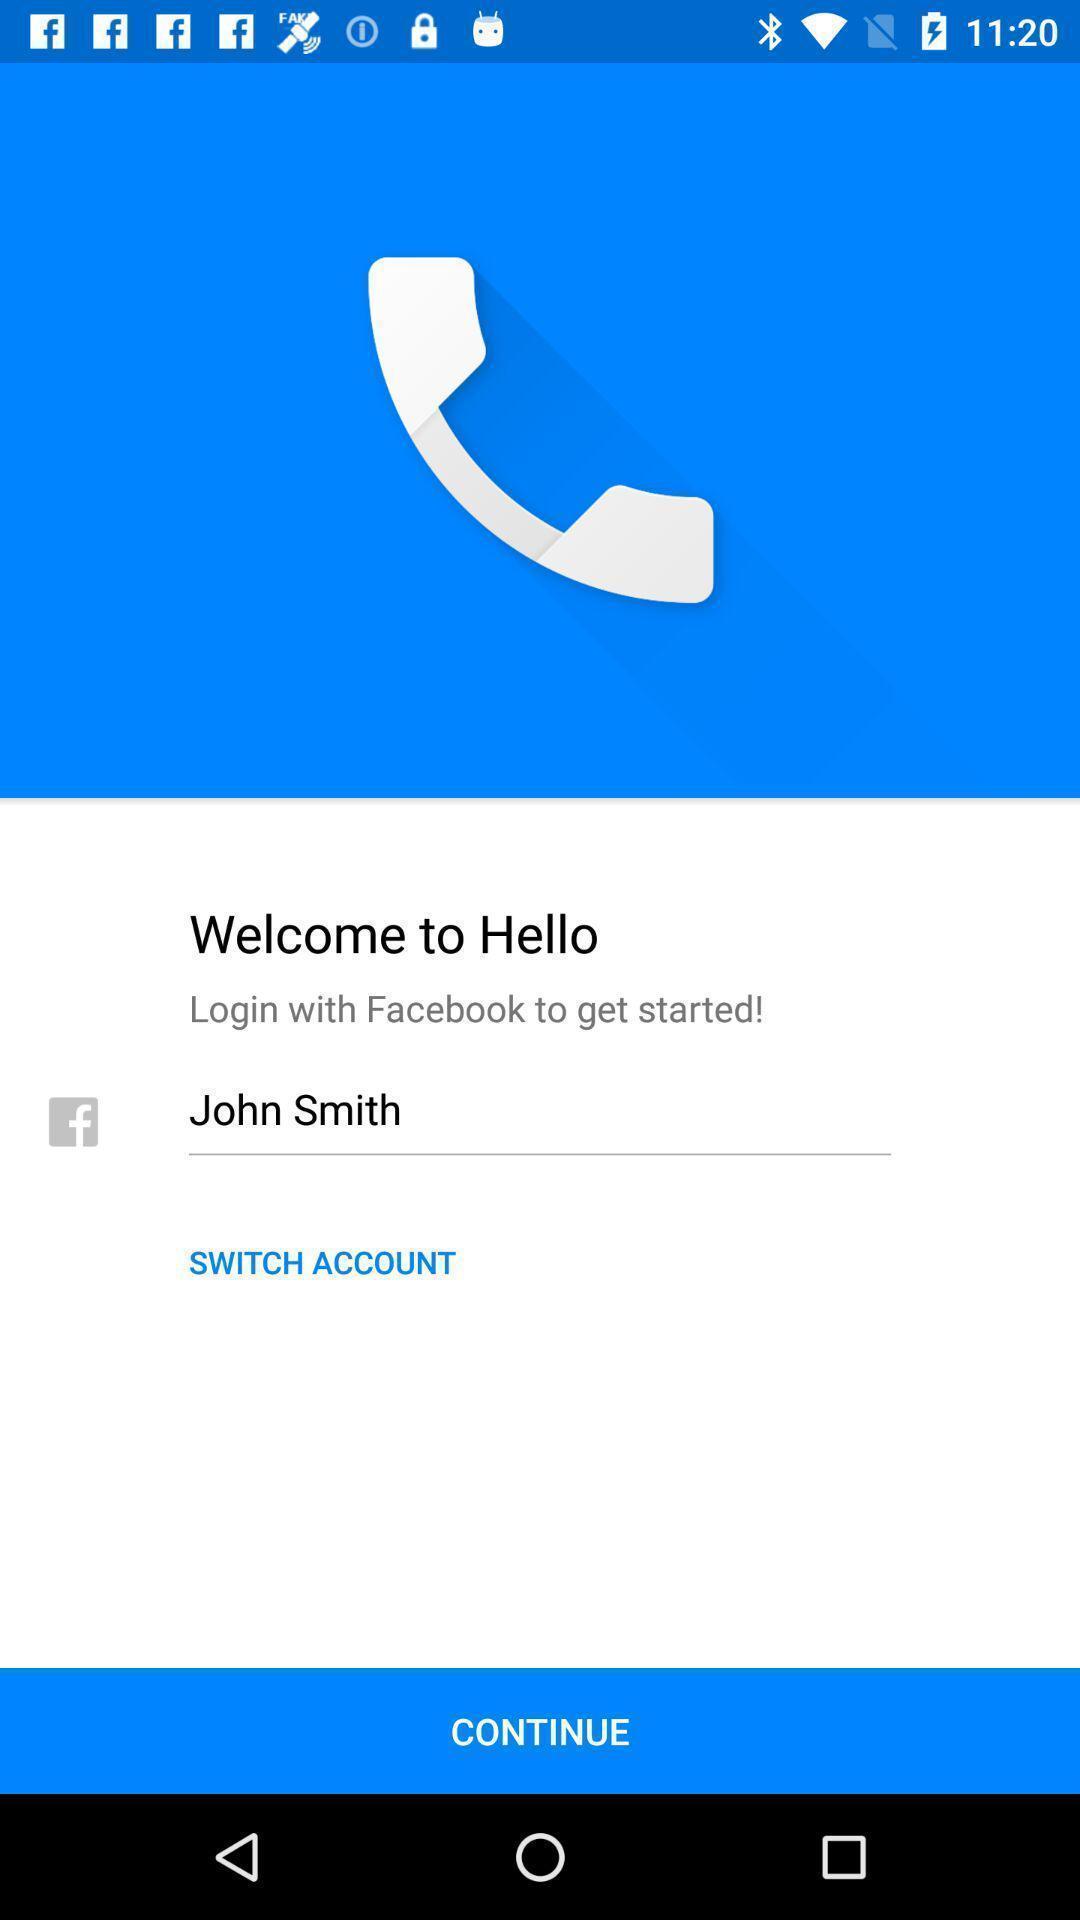What is the overall content of this screenshot? Welcome page of the app. 